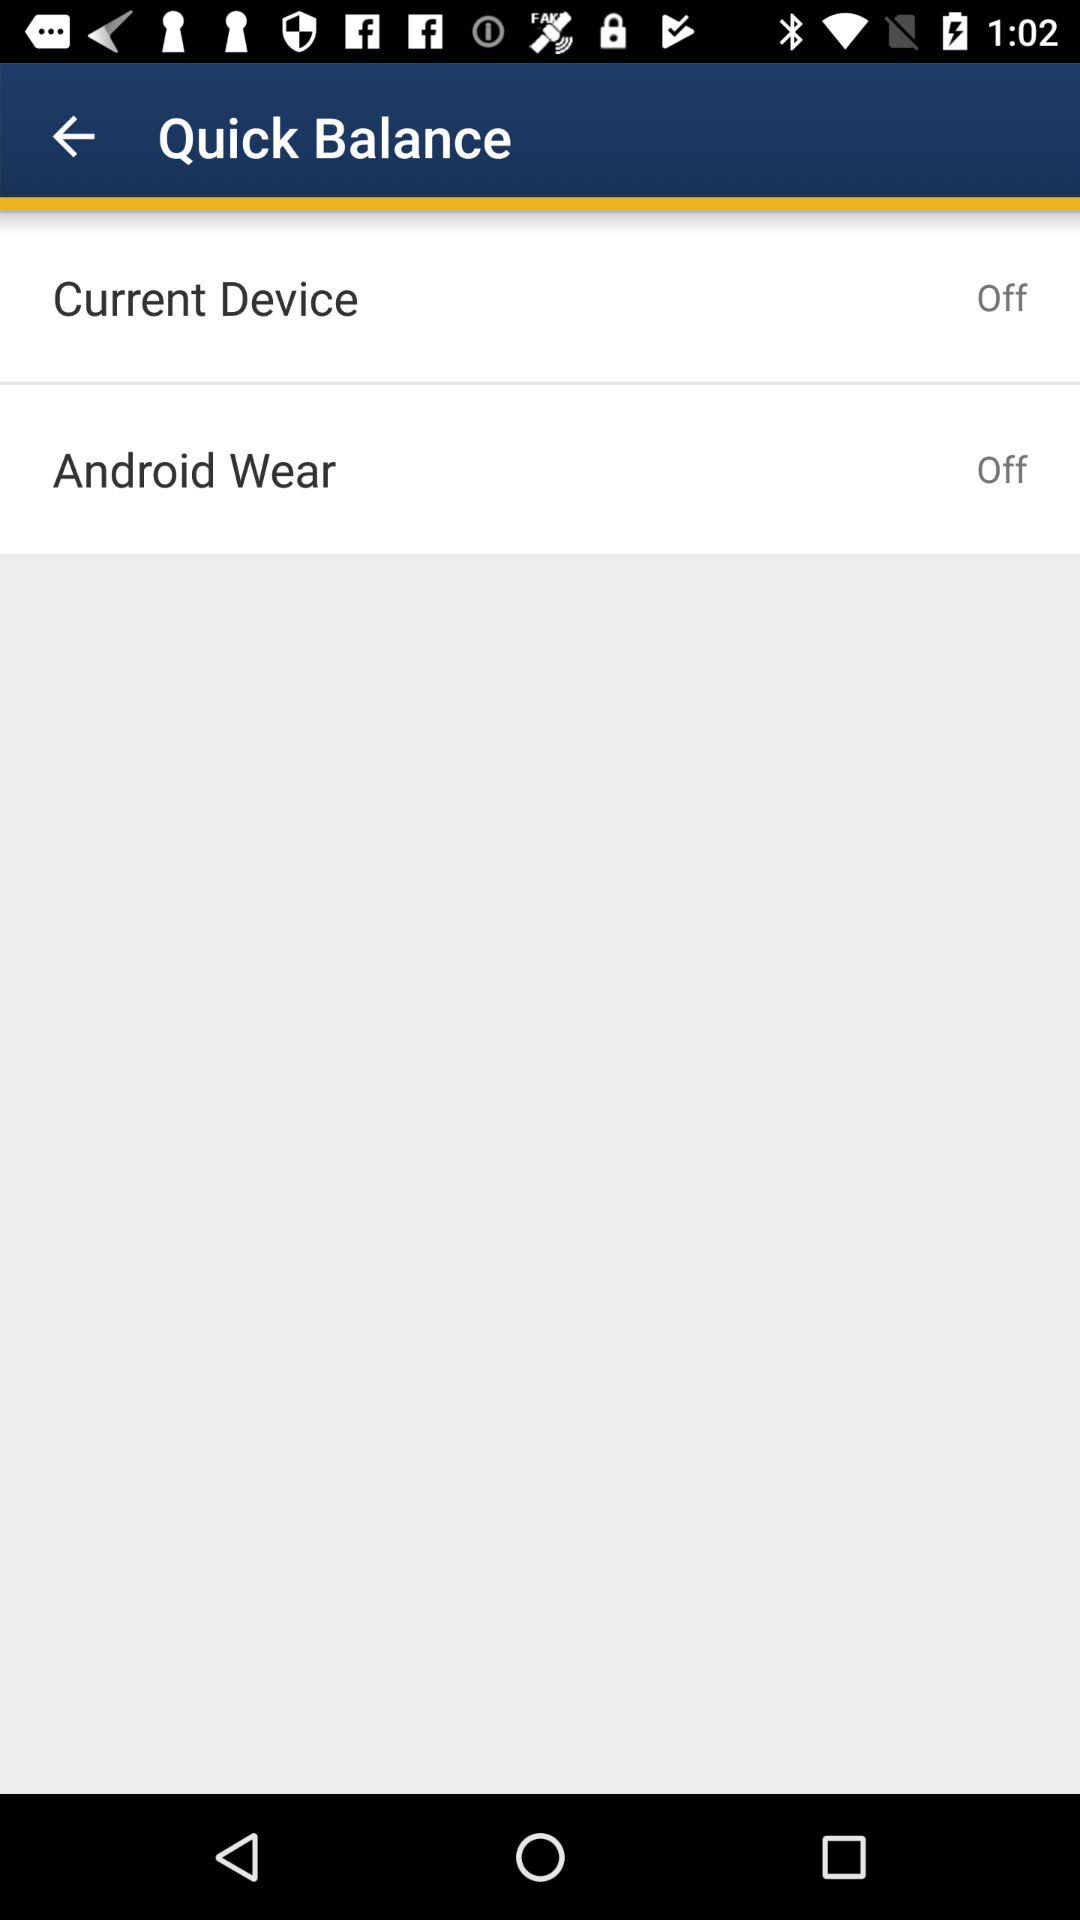What is the status of "Android Wear"? The status of "Android Wear" is "off". 